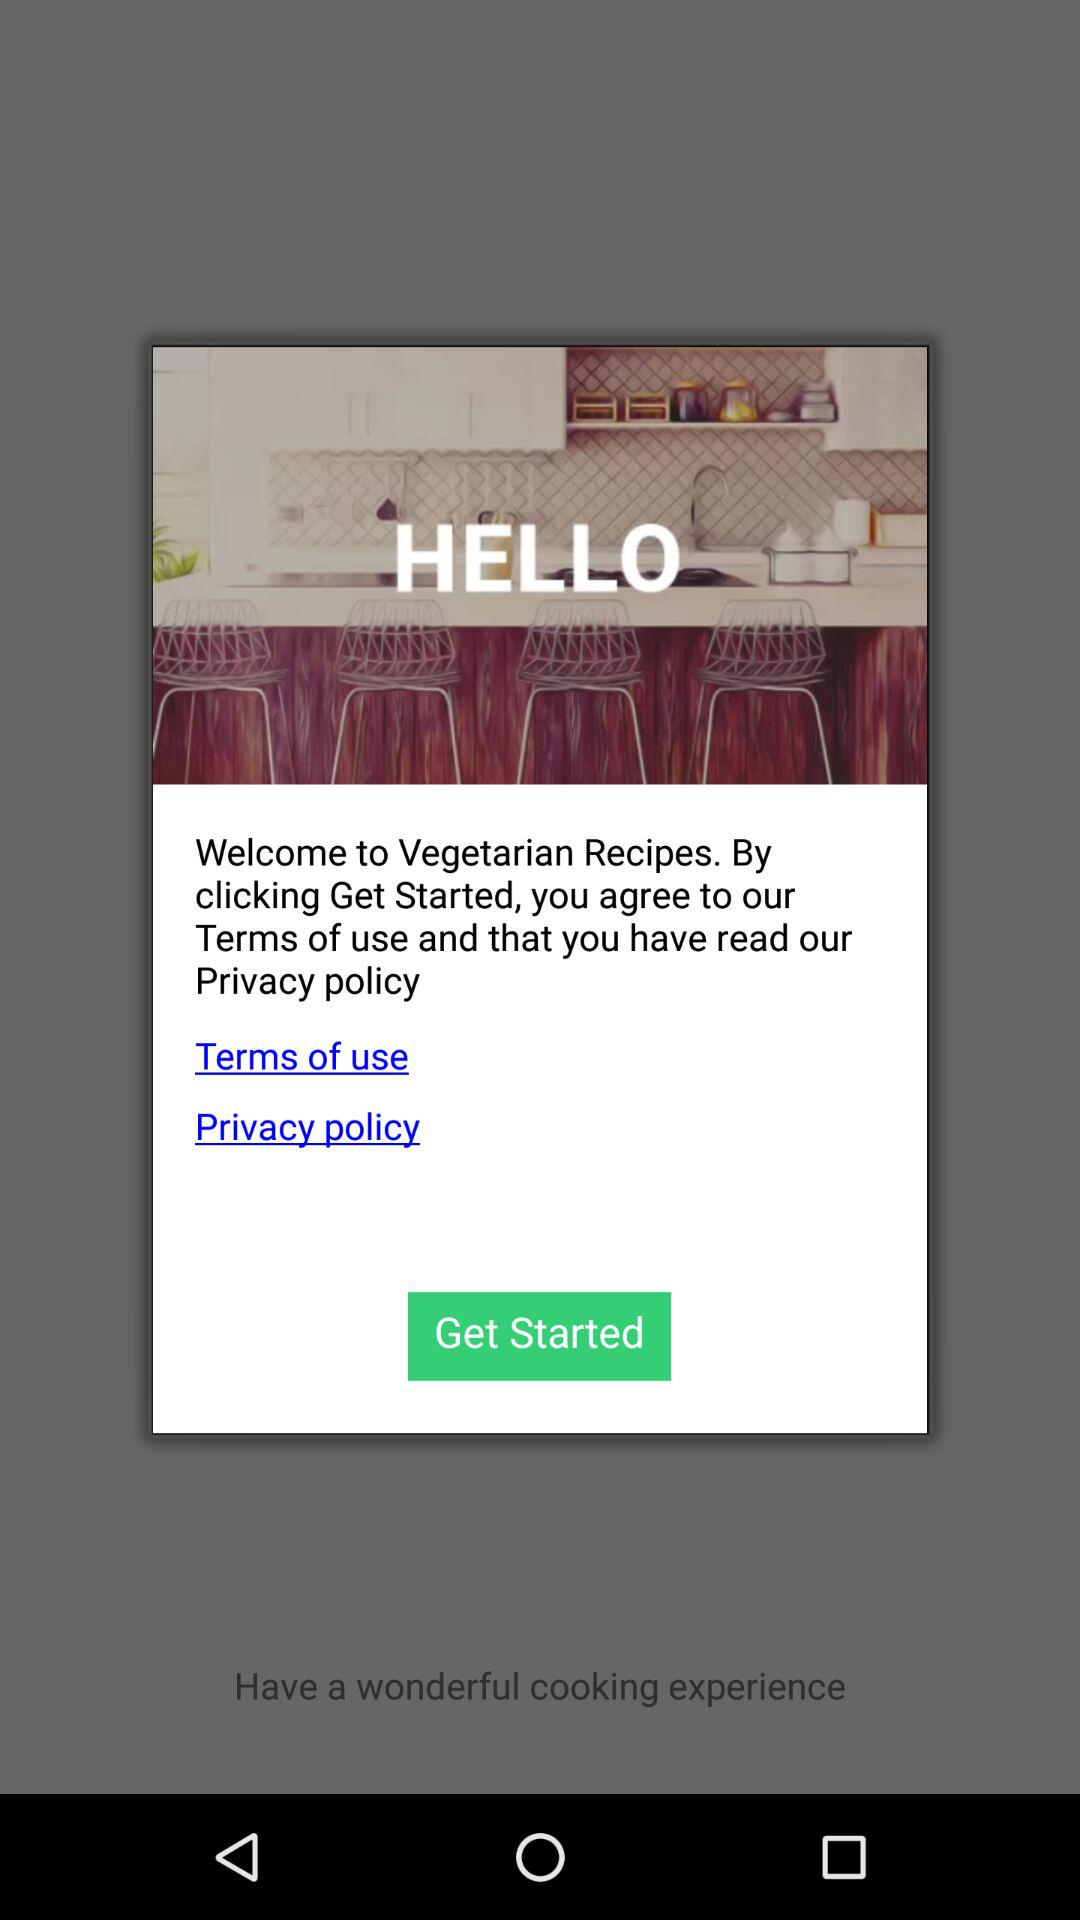How do you sign up for "Vegetarian Recipes"?
When the provided information is insufficient, respond with <no answer>. <no answer> 